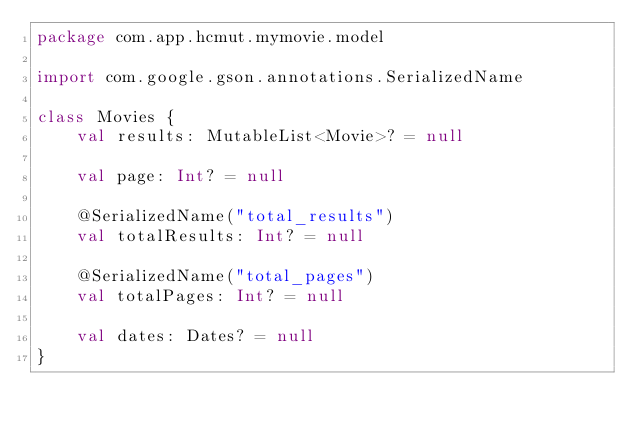Convert code to text. <code><loc_0><loc_0><loc_500><loc_500><_Kotlin_>package com.app.hcmut.mymovie.model

import com.google.gson.annotations.SerializedName

class Movies {
    val results: MutableList<Movie>? = null

    val page: Int? = null

    @SerializedName("total_results")
    val totalResults: Int? = null

    @SerializedName("total_pages")
    val totalPages: Int? = null

    val dates: Dates? = null
}</code> 